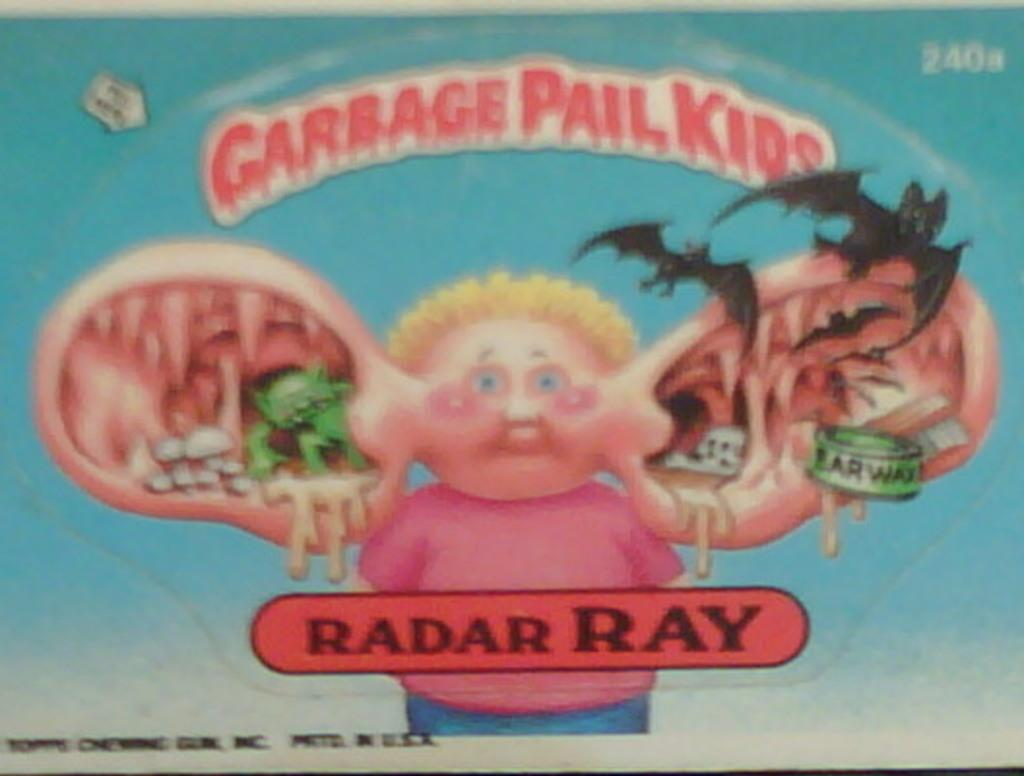<image>
Share a concise interpretation of the image provided. Radar Ray has creepy and disgusting things coming out of his enormous ears. 